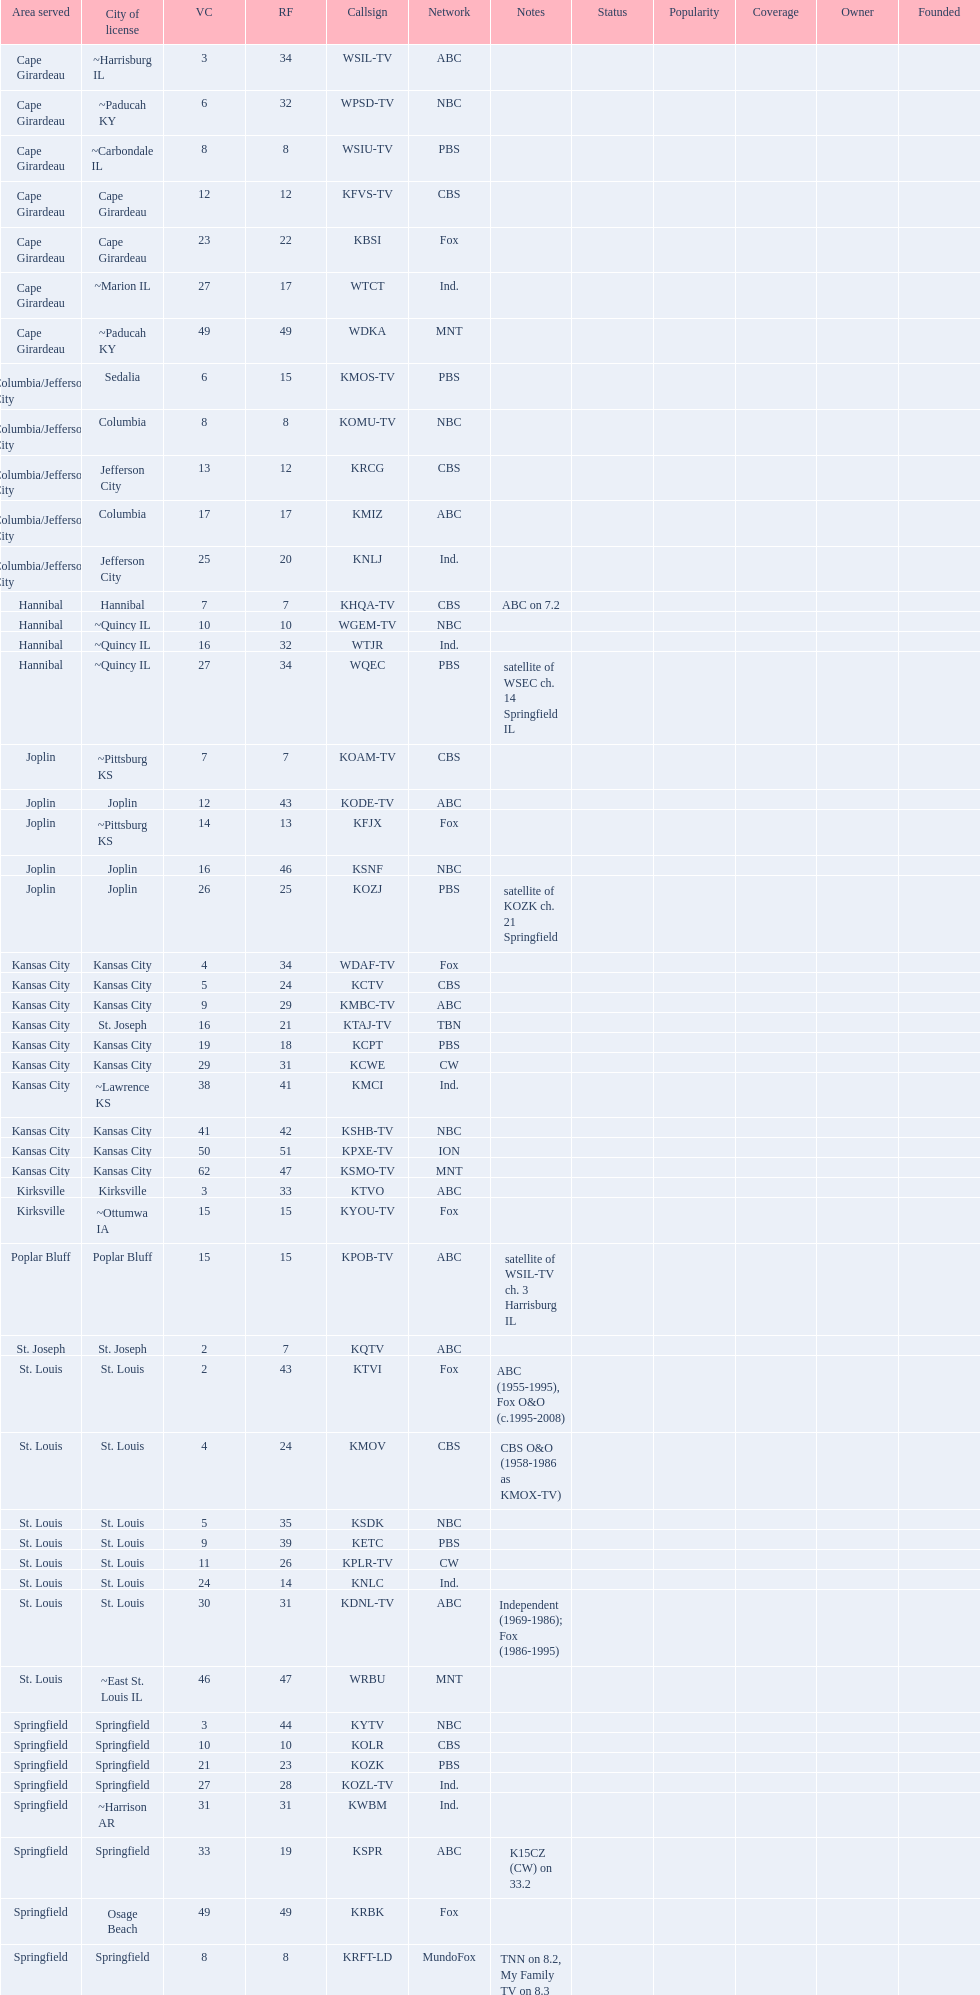How many locations have 5 or more stations? 6. 